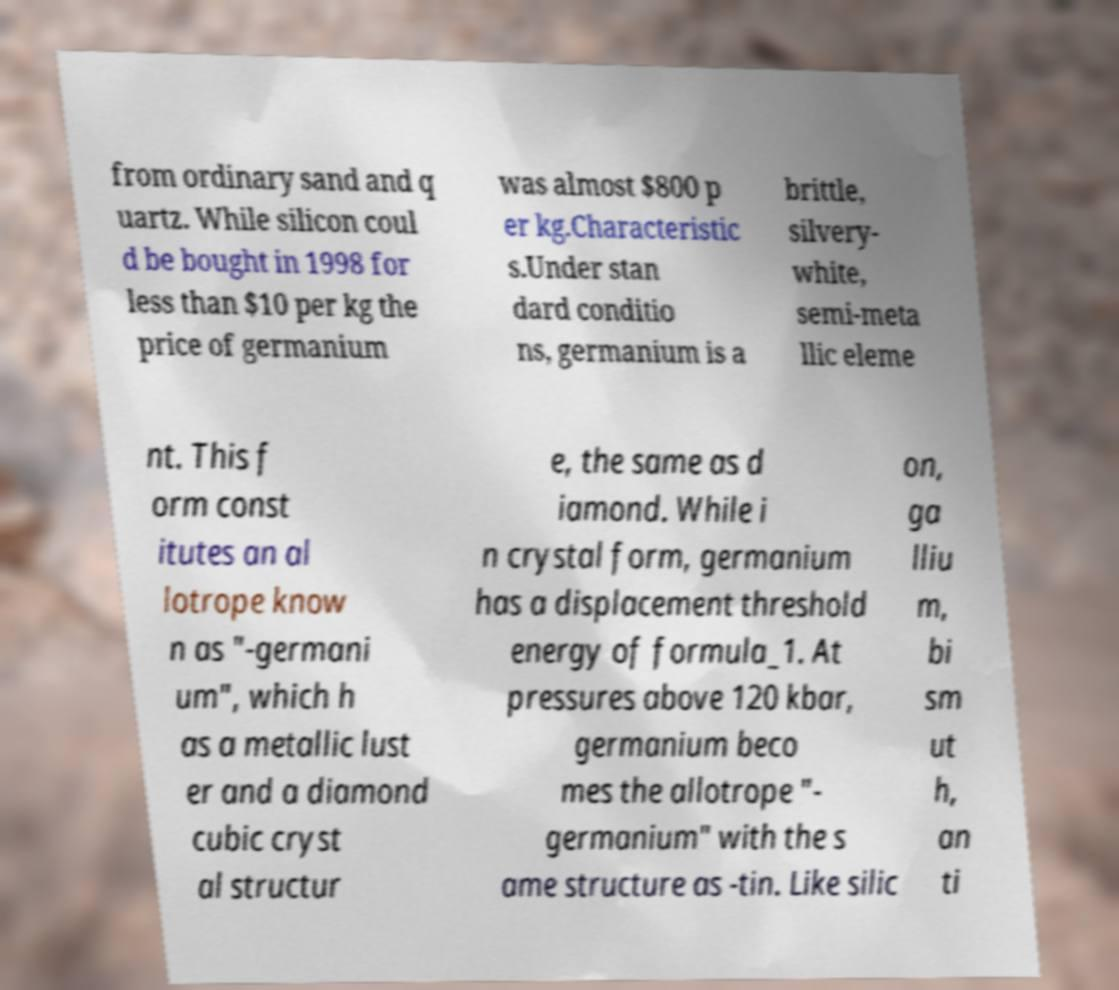Please identify and transcribe the text found in this image. from ordinary sand and q uartz. While silicon coul d be bought in 1998 for less than $10 per kg the price of germanium was almost $800 p er kg.Characteristic s.Under stan dard conditio ns, germanium is a brittle, silvery- white, semi-meta llic eleme nt. This f orm const itutes an al lotrope know n as "-germani um", which h as a metallic lust er and a diamond cubic cryst al structur e, the same as d iamond. While i n crystal form, germanium has a displacement threshold energy of formula_1. At pressures above 120 kbar, germanium beco mes the allotrope "- germanium" with the s ame structure as -tin. Like silic on, ga lliu m, bi sm ut h, an ti 